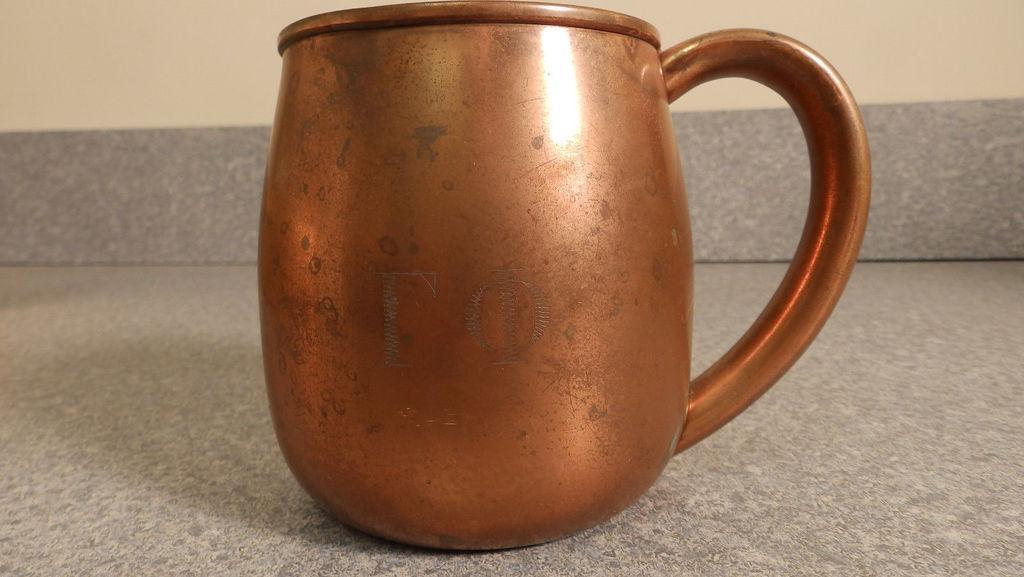In one or two sentences, can you explain what this image depicts? In this image in the center there is one cup and in the background there is a wall, at the bottom there is a floor. 